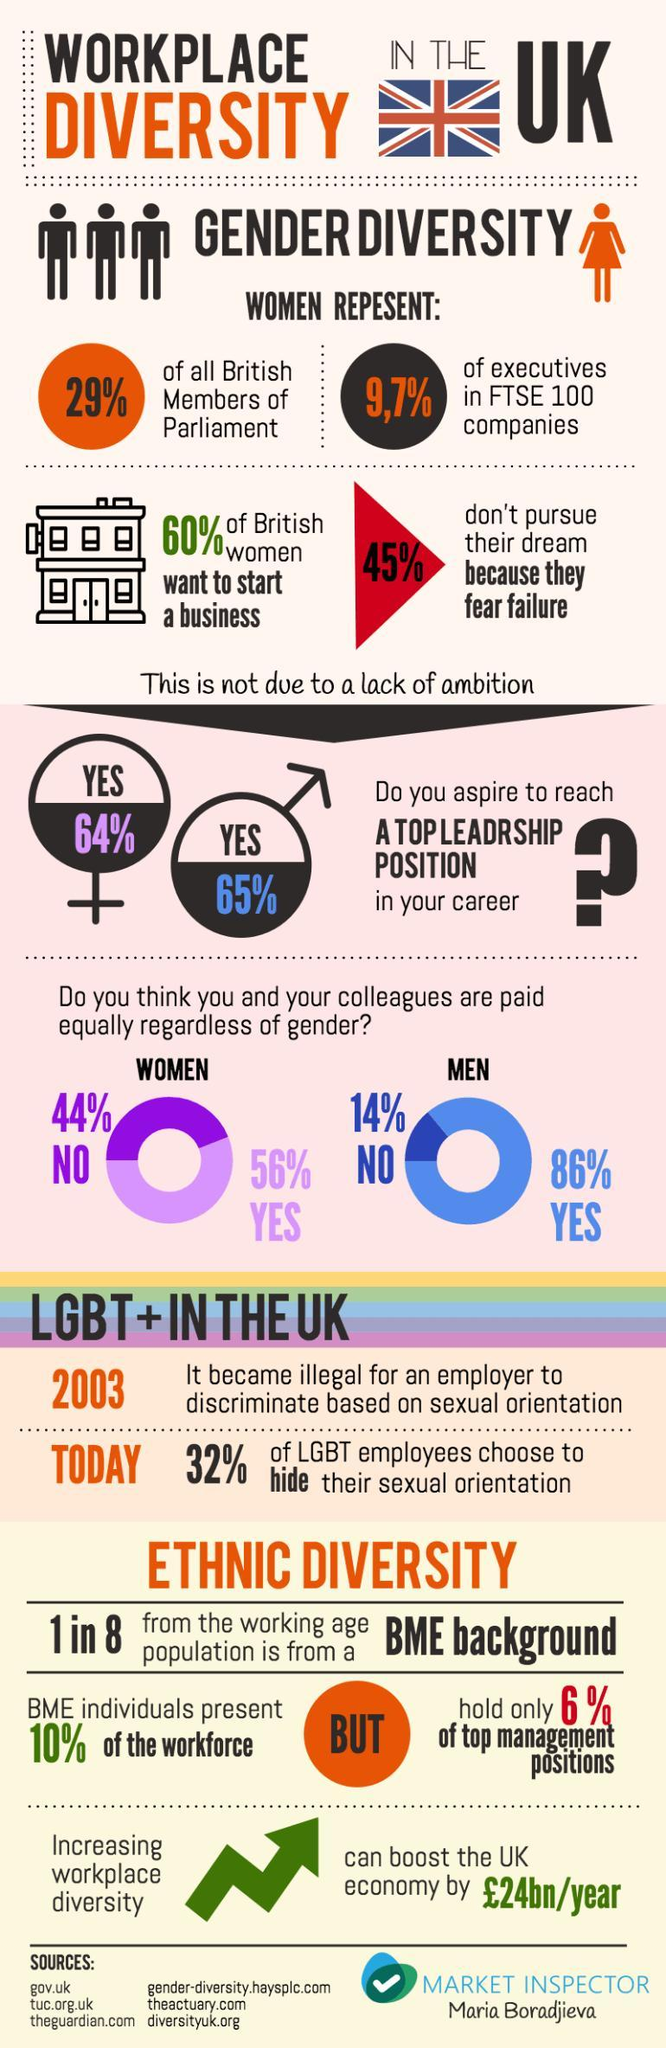What percentage of women in UK aspire to reach a top leadership position in their career according to the survey?
Answer the question with a short phrase. 64% What percentage of BME individuals hold the top management positions in the UK according to the survey? 6% What percentage of men in UK think that they are equally paid regardless of their gender as per the survey? 86% What percentage of women in UK think that they are equally paid regardless of their gender as per the survey? 56% What percentage of LGBT employees in UK do not choose to hide their sexual orientation as per the survey? 68% What percentage of men in UK aspire to reach a top leadership position in their career according to the survey? 65% 